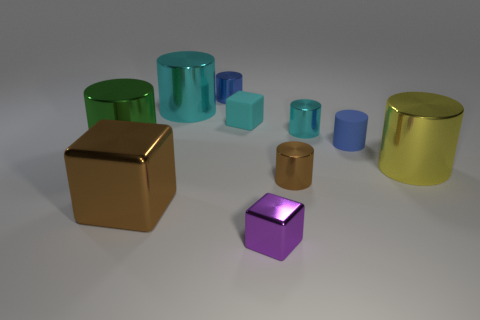There is a matte cylinder; is its color the same as the tiny cube that is in front of the brown cylinder?
Ensure brevity in your answer.  No. The yellow thing that is made of the same material as the small brown cylinder is what size?
Give a very brief answer. Large. Is there a large metal ball of the same color as the tiny matte cube?
Offer a terse response. No. What number of things are large metal cylinders that are behind the green shiny thing or tiny blocks?
Keep it short and to the point. 3. Are the big green thing and the small blue thing in front of the tiny cyan metallic cylinder made of the same material?
Provide a succinct answer. No. There is a cylinder that is the same color as the big metallic cube; what size is it?
Your answer should be very brief. Small. Are there any small cyan cylinders that have the same material as the purple object?
Keep it short and to the point. Yes. What number of objects are either small cylinders in front of the blue matte cylinder or objects in front of the yellow cylinder?
Make the answer very short. 3. Do the small cyan matte thing and the big shiny object right of the tiny metal block have the same shape?
Ensure brevity in your answer.  No. What number of other objects are there of the same shape as the tiny cyan metallic thing?
Your response must be concise. 6. 